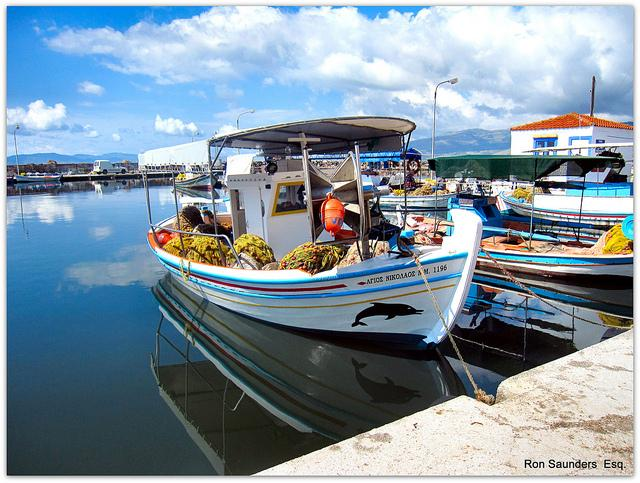What yellow items sits on the boat? Please explain your reasoning. net. The item looks to be made of material formed in the shape of a net. 